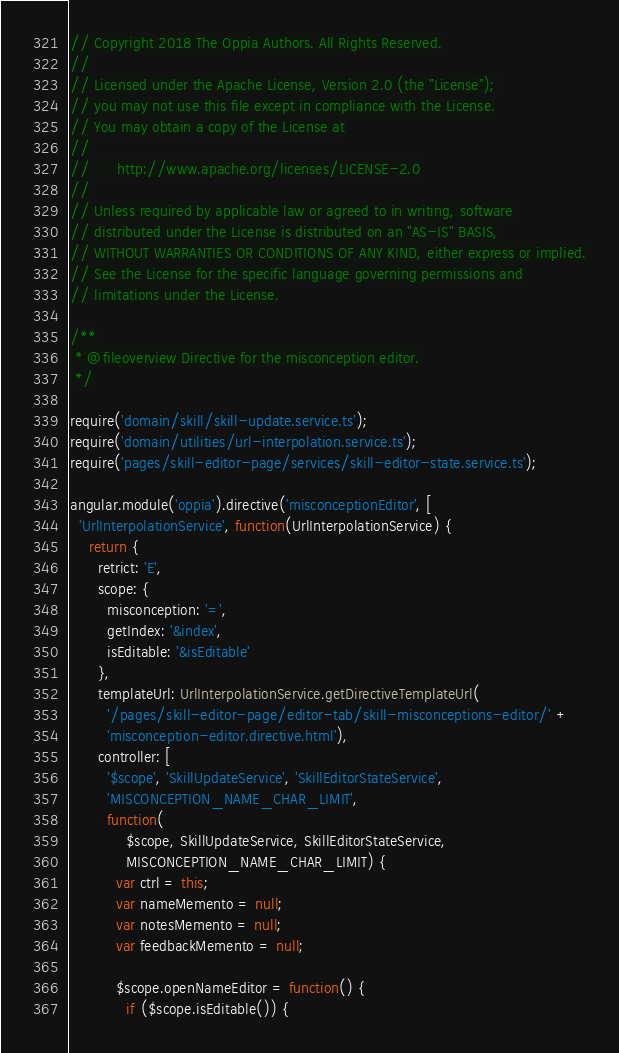Convert code to text. <code><loc_0><loc_0><loc_500><loc_500><_TypeScript_>// Copyright 2018 The Oppia Authors. All Rights Reserved.
//
// Licensed under the Apache License, Version 2.0 (the "License");
// you may not use this file except in compliance with the License.
// You may obtain a copy of the License at
//
//      http://www.apache.org/licenses/LICENSE-2.0
//
// Unless required by applicable law or agreed to in writing, software
// distributed under the License is distributed on an "AS-IS" BASIS,
// WITHOUT WARRANTIES OR CONDITIONS OF ANY KIND, either express or implied.
// See the License for the specific language governing permissions and
// limitations under the License.

/**
 * @fileoverview Directive for the misconception editor.
 */

require('domain/skill/skill-update.service.ts');
require('domain/utilities/url-interpolation.service.ts');
require('pages/skill-editor-page/services/skill-editor-state.service.ts');

angular.module('oppia').directive('misconceptionEditor', [
  'UrlInterpolationService', function(UrlInterpolationService) {
    return {
      retrict: 'E',
      scope: {
        misconception: '=',
        getIndex: '&index',
        isEditable: '&isEditable'
      },
      templateUrl: UrlInterpolationService.getDirectiveTemplateUrl(
        '/pages/skill-editor-page/editor-tab/skill-misconceptions-editor/' +
        'misconception-editor.directive.html'),
      controller: [
        '$scope', 'SkillUpdateService', 'SkillEditorStateService',
        'MISCONCEPTION_NAME_CHAR_LIMIT',
        function(
            $scope, SkillUpdateService, SkillEditorStateService,
            MISCONCEPTION_NAME_CHAR_LIMIT) {
          var ctrl = this;
          var nameMemento = null;
          var notesMemento = null;
          var feedbackMemento = null;

          $scope.openNameEditor = function() {
            if ($scope.isEditable()) {</code> 